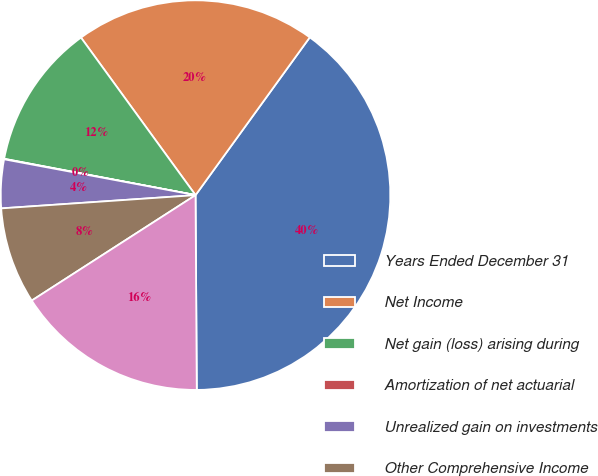Convert chart to OTSL. <chart><loc_0><loc_0><loc_500><loc_500><pie_chart><fcel>Years Ended December 31<fcel>Net Income<fcel>Net gain (loss) arising during<fcel>Amortization of net actuarial<fcel>Unrealized gain on investments<fcel>Other Comprehensive Income<fcel>Comprehensive Income<nl><fcel>39.93%<fcel>19.98%<fcel>12.01%<fcel>0.04%<fcel>4.03%<fcel>8.02%<fcel>16.0%<nl></chart> 